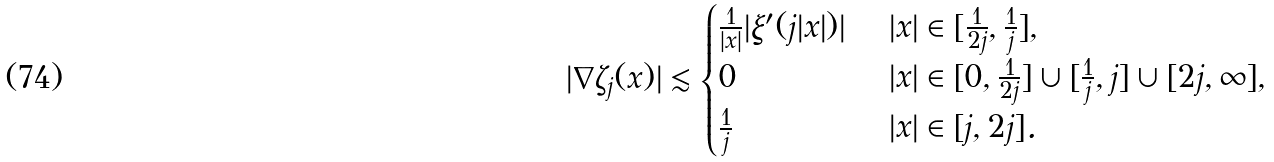<formula> <loc_0><loc_0><loc_500><loc_500>| \nabla \zeta _ { j } ( x ) | \lesssim \begin{cases} \frac { 1 } { | x | } | \xi ^ { \prime } ( j | x | ) | & \ | x | \in [ \frac { 1 } { 2 j } , \frac { 1 } { j } ] , \\ 0 & \ | x | \in [ 0 , \frac { 1 } { 2 j } ] \cup [ \frac { 1 } { j } , j ] \cup [ 2 j , \infty ] , \\ \frac { 1 } { j } & \ | x | \in [ j , 2 j ] . \end{cases}</formula> 